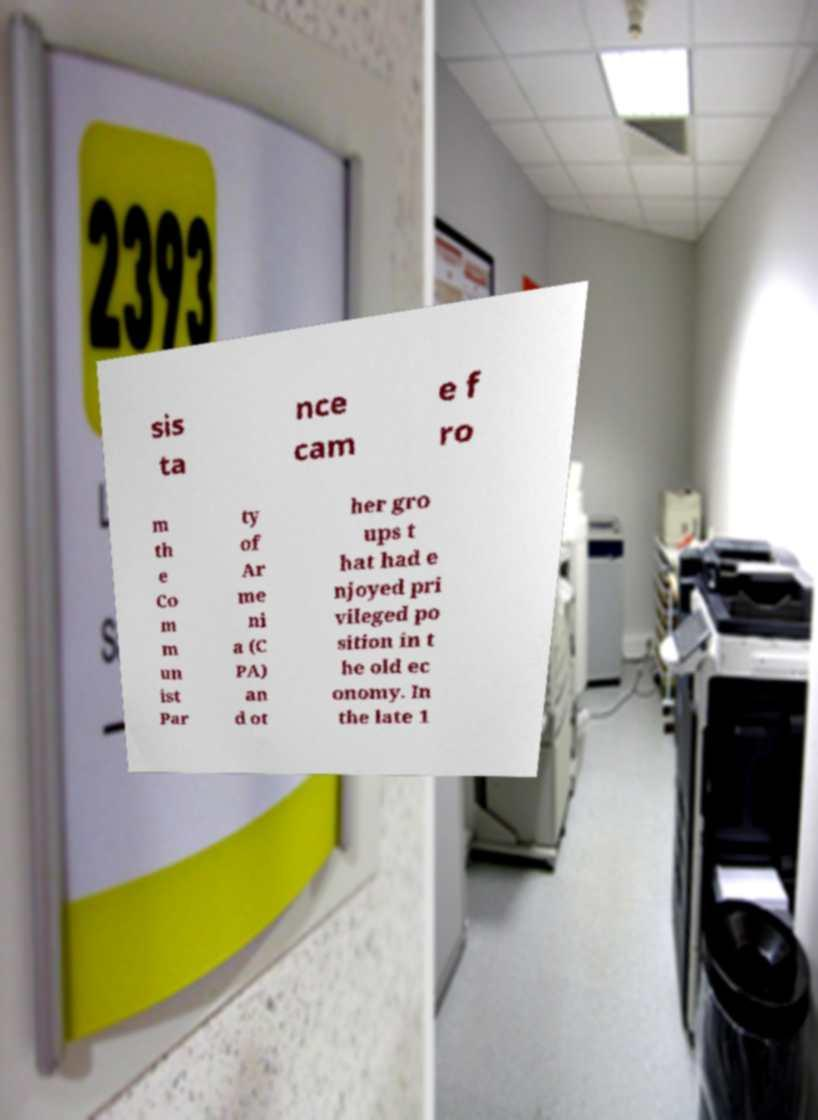I need the written content from this picture converted into text. Can you do that? sis ta nce cam e f ro m th e Co m m un ist Par ty of Ar me ni a (C PA) an d ot her gro ups t hat had e njoyed pri vileged po sition in t he old ec onomy. In the late 1 